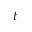Convert formula to latex. <formula><loc_0><loc_0><loc_500><loc_500>t</formula> 